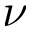<formula> <loc_0><loc_0><loc_500><loc_500>\nu</formula> 